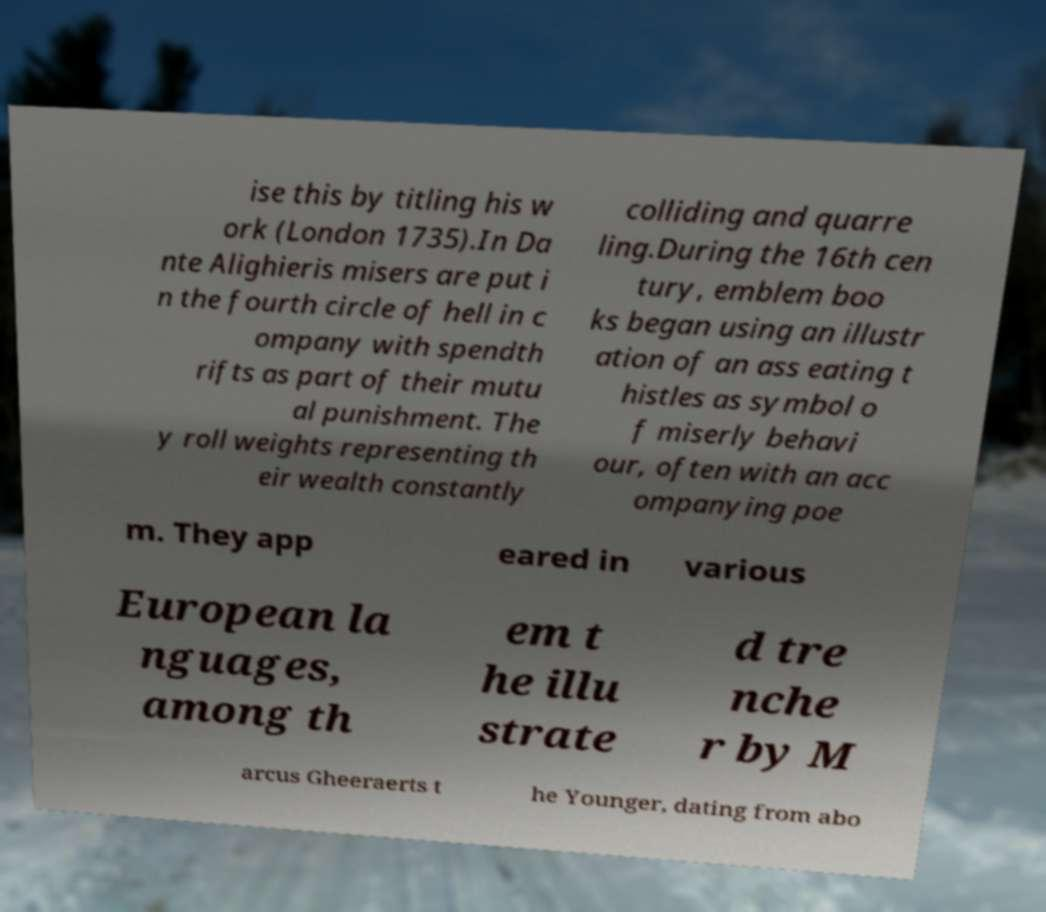Could you assist in decoding the text presented in this image and type it out clearly? ise this by titling his w ork (London 1735).In Da nte Alighieris misers are put i n the fourth circle of hell in c ompany with spendth rifts as part of their mutu al punishment. The y roll weights representing th eir wealth constantly colliding and quarre ling.During the 16th cen tury, emblem boo ks began using an illustr ation of an ass eating t histles as symbol o f miserly behavi our, often with an acc ompanying poe m. They app eared in various European la nguages, among th em t he illu strate d tre nche r by M arcus Gheeraerts t he Younger, dating from abo 